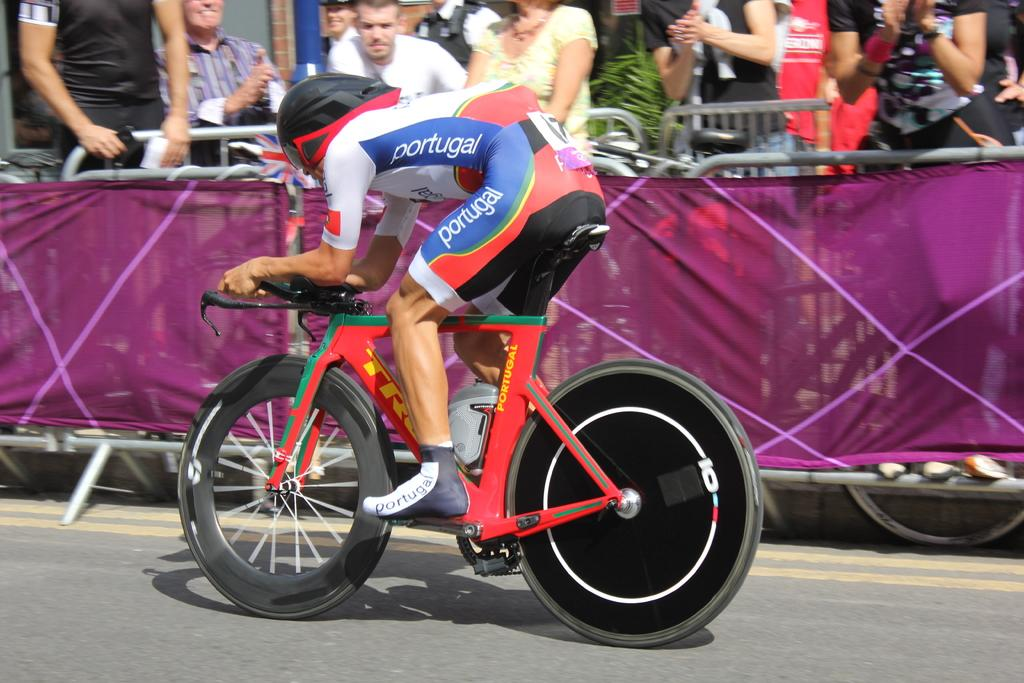Who is the main subject in the image? There is a man in the image. What is the man doing in the image? The man is riding a bicycle. Can you describe the people in the background of the image? The people in the background are watching the man on the bicycle. What type of glove is the man wearing while riding the bicycle in the image? There is no glove mentioned or visible in the image; the man is simply riding a bicycle. 